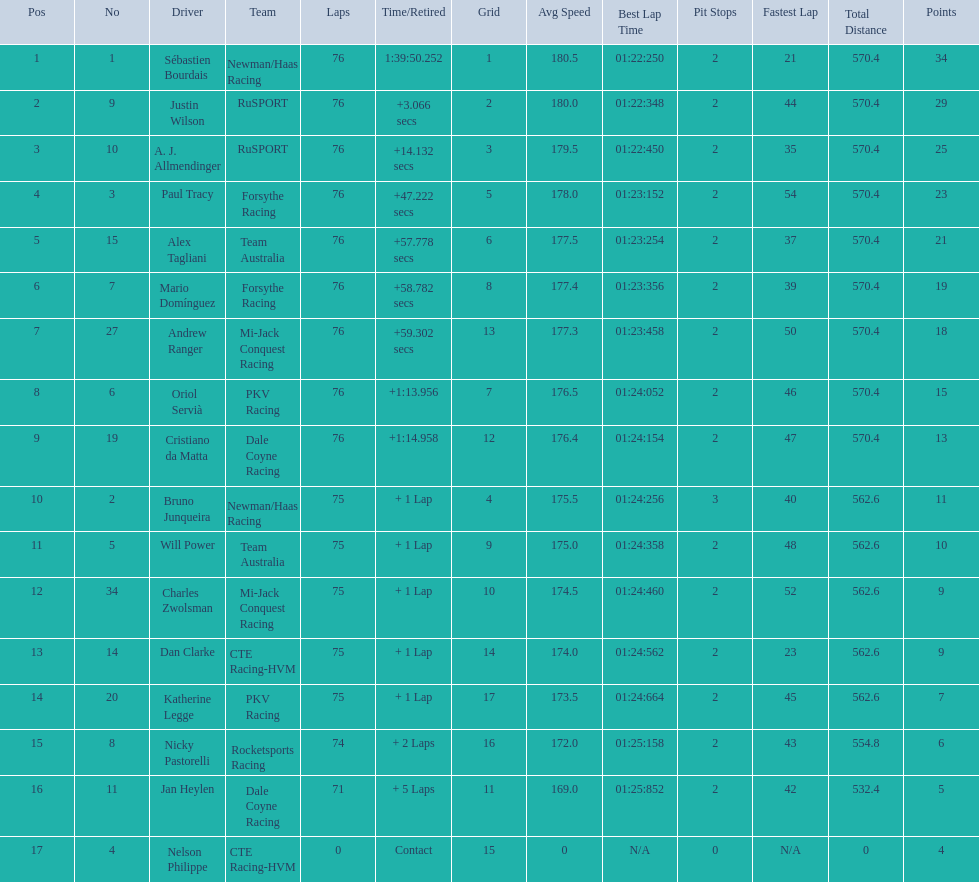What drivers took part in the 2006 tecate grand prix of monterrey? Sébastien Bourdais, Justin Wilson, A. J. Allmendinger, Paul Tracy, Alex Tagliani, Mario Domínguez, Andrew Ranger, Oriol Servià, Cristiano da Matta, Bruno Junqueira, Will Power, Charles Zwolsman, Dan Clarke, Katherine Legge, Nicky Pastorelli, Jan Heylen, Nelson Philippe. Which of those drivers scored the same amount of points as another driver? Charles Zwolsman, Dan Clarke. Who had the same amount of points as charles zwolsman? Dan Clarke. 